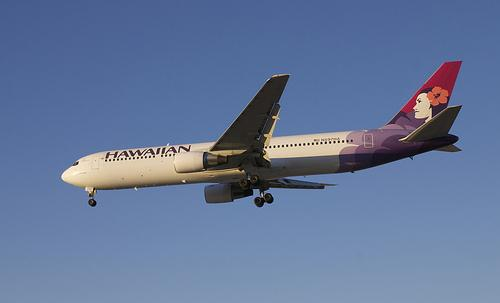How would you describe the woman figure on the plane tail? The woman figure has a flower in her hair. Mention one aspect of the plane's appearance that suggests it's a Hawaiian Airlines flight. There is the word "Hawaiian" written on the plane's body. What is the primary object in the image and what action is it performing? The primary object is a red and white plane, and it is preparing for landing in flight. What important detail can you notice about the plane's windows? The plane has small windows and a row of windows on the left side. What color is the back part of the plane, and what feature can you see on the tail? The back part of the plane is painted purple, and there is a logo of a lady on its tail. Describe the color and design of the plane in the image. The plane is red and white with a purple section at the back, and it has small windows and a lady figure with a flower in her hair on its tail. Count the number of clouds present in the image. There are 9 clouds present in the image. What sentiment or feeling might one get from observing the sky and clouds in the image? A sense of calmness and serenity might be experienced from observing the sky and clouds. Identify three distinct parts of the plane that are mentioned in the image annotations. Three distinct parts of the plane are the cockpit, the landing gear, and the left engine. 